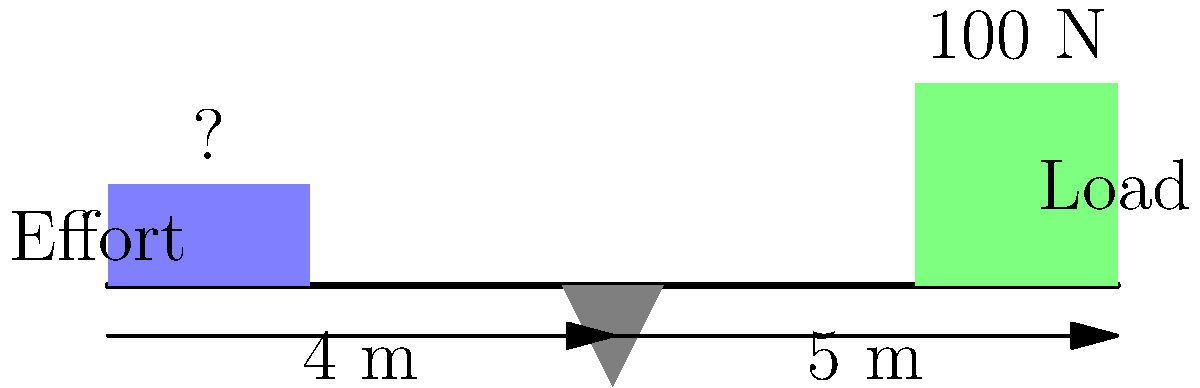As a sustainable farmer, you're using a lever to lift a heavy load of organic compost. The lever is 9 meters long with the fulcrum placed 4 meters from where you're applying the effort. If the load weighs 100 N and is placed at the end of the lever, what minimum force must you apply to lift the load? Let's solve this step-by-step using the principle of moments for a lever:

1) The mechanical advantage of a lever is given by the ratio of the effort arm to the load arm.

2) In this case:
   - Effort arm (distance from fulcrum to effort) = 4 m
   - Load arm (distance from fulcrum to load) = 5 m

3) For equilibrium, the sum of moments about the fulcrum must be zero:
   $$(F_e \times 4) = (100 \times 5)$$
   Where $F_e$ is the effort force we're trying to find.

4) Rearranging the equation:
   $$F_e = \frac{100 \times 5}{4} = \frac{500}{4} = 125\text{ N}$$

5) Therefore, you need to apply a minimum force of 125 N to lift the 100 N load.

This demonstrates how simple machines like levers can provide a mechanical advantage in sustainable farming practices, allowing farmers to lift heavier loads with less effort.
Answer: 125 N 